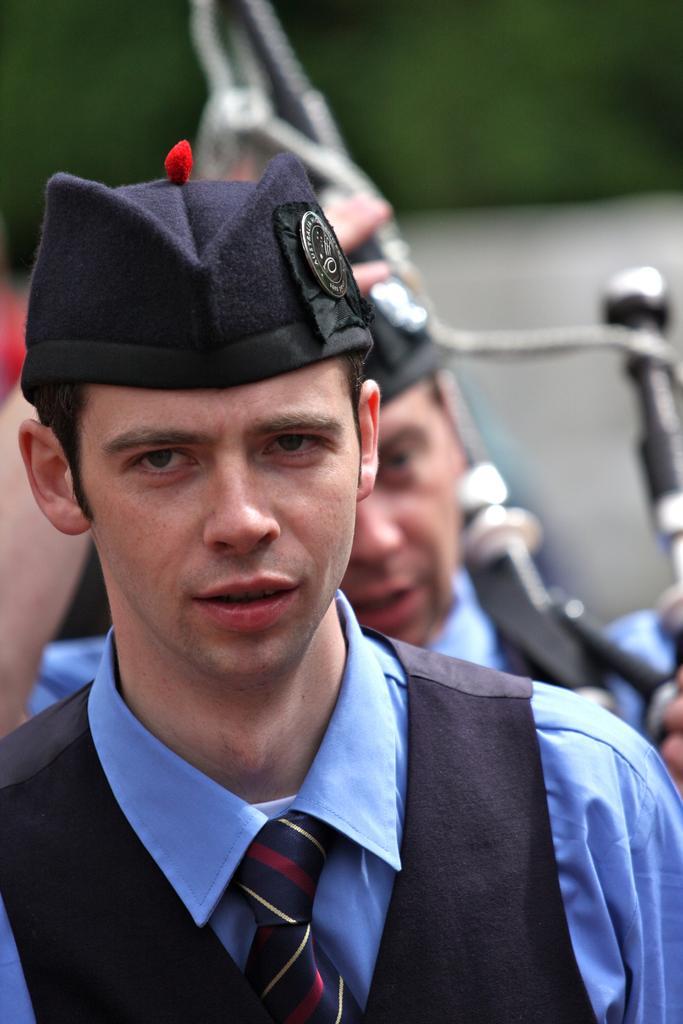Can you describe this image briefly? In this image we can see a person wearing blue color dress, black color suit and in the background of the image there is a person wearing similar dress standing and holding some object in his hands. 